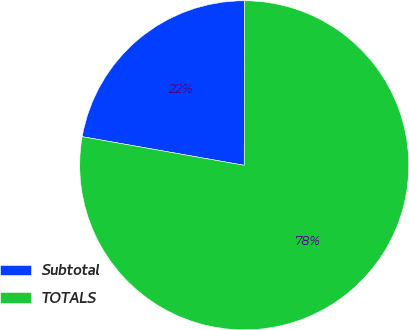<chart> <loc_0><loc_0><loc_500><loc_500><pie_chart><fcel>Subtotal<fcel>TOTALS<nl><fcel>22.25%<fcel>77.75%<nl></chart> 